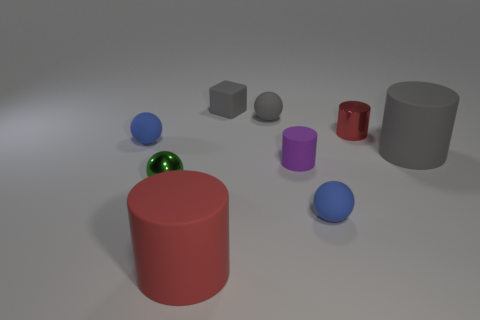What color is the other small thing that is the same shape as the small red thing?
Keep it short and to the point. Purple. Is the green object made of the same material as the blue ball left of the red matte object?
Offer a very short reply. No. What color is the small matte cylinder?
Give a very brief answer. Purple. There is a small metal thing right of the red cylinder in front of the gray thing that is to the right of the purple cylinder; what color is it?
Make the answer very short. Red. Does the small purple matte object have the same shape as the big thing on the left side of the small metal cylinder?
Ensure brevity in your answer.  Yes. There is a ball that is both behind the tiny green metal sphere and in front of the tiny red metallic thing; what color is it?
Your response must be concise. Blue. Is there another green metal object that has the same shape as the green object?
Offer a terse response. No. Do the small shiny cylinder and the small shiny ball have the same color?
Make the answer very short. No. There is a red cylinder that is in front of the small red object; is there a matte block on the left side of it?
Your answer should be compact. No. How many objects are blue spheres in front of the big gray matte thing or small balls that are left of the large gray matte cylinder?
Ensure brevity in your answer.  4. 